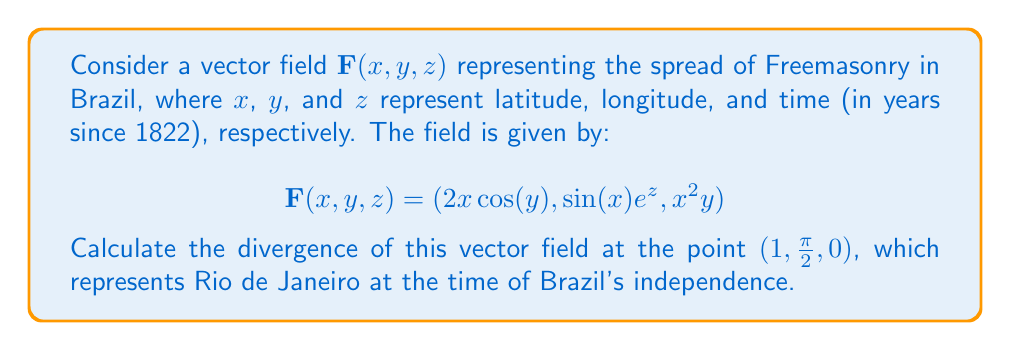Help me with this question. To calculate the divergence of the vector field, we need to use the formula:

$$\text{div}\mathbf{F} = \nabla \cdot \mathbf{F} = \frac{\partial F_x}{\partial x} + \frac{\partial F_y}{\partial y} + \frac{\partial F_z}{\partial z}$$

Let's calculate each partial derivative:

1) $\frac{\partial F_x}{\partial x} = \frac{\partial}{\partial x}(2x\cos(y)) = 2\cos(y)$

2) $\frac{\partial F_y}{\partial y} = \frac{\partial}{\partial y}(\sin(x)e^z) = 0$

3) $\frac{\partial F_z}{\partial z} = \frac{\partial}{\partial z}(x^2y) = 0$

Now, we sum these partial derivatives:

$$\text{div}\mathbf{F} = 2\cos(y) + 0 + 0 = 2\cos(y)$$

To find the divergence at the point $(1, \frac{\pi}{2}, 0)$, we substitute $y = \frac{\pi}{2}$:

$$\text{div}\mathbf{F}(1, \frac{\pi}{2}, 0) = 2\cos(\frac{\pi}{2}) = 2 \cdot 0 = 0$$

Therefore, the divergence of the vector field at the given point is 0.
Answer: $0$ 